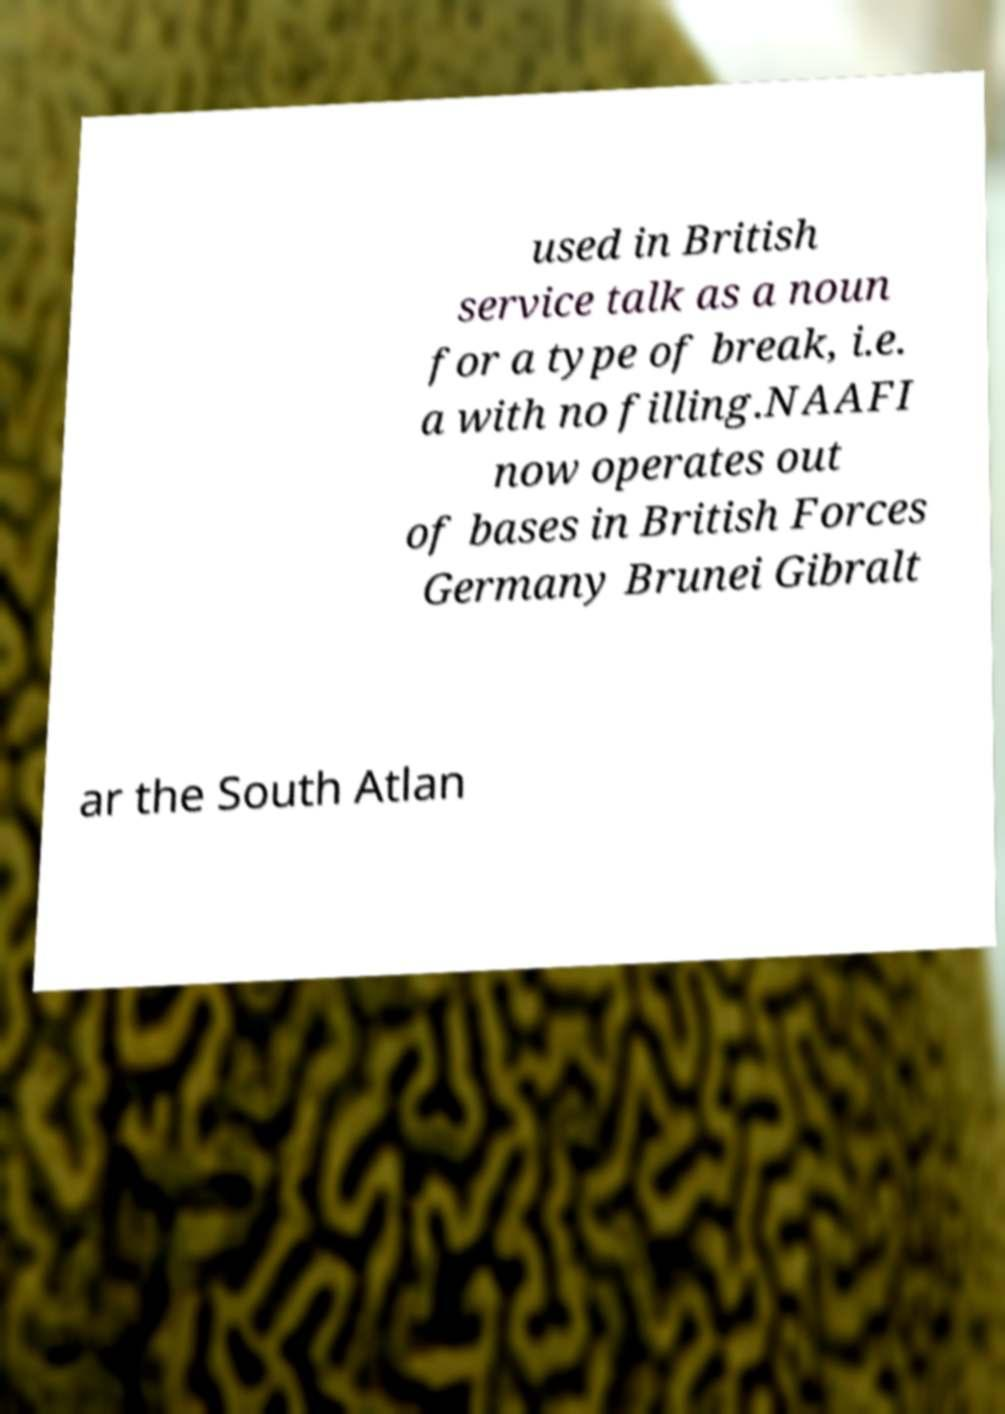I need the written content from this picture converted into text. Can you do that? used in British service talk as a noun for a type of break, i.e. a with no filling.NAAFI now operates out of bases in British Forces Germany Brunei Gibralt ar the South Atlan 